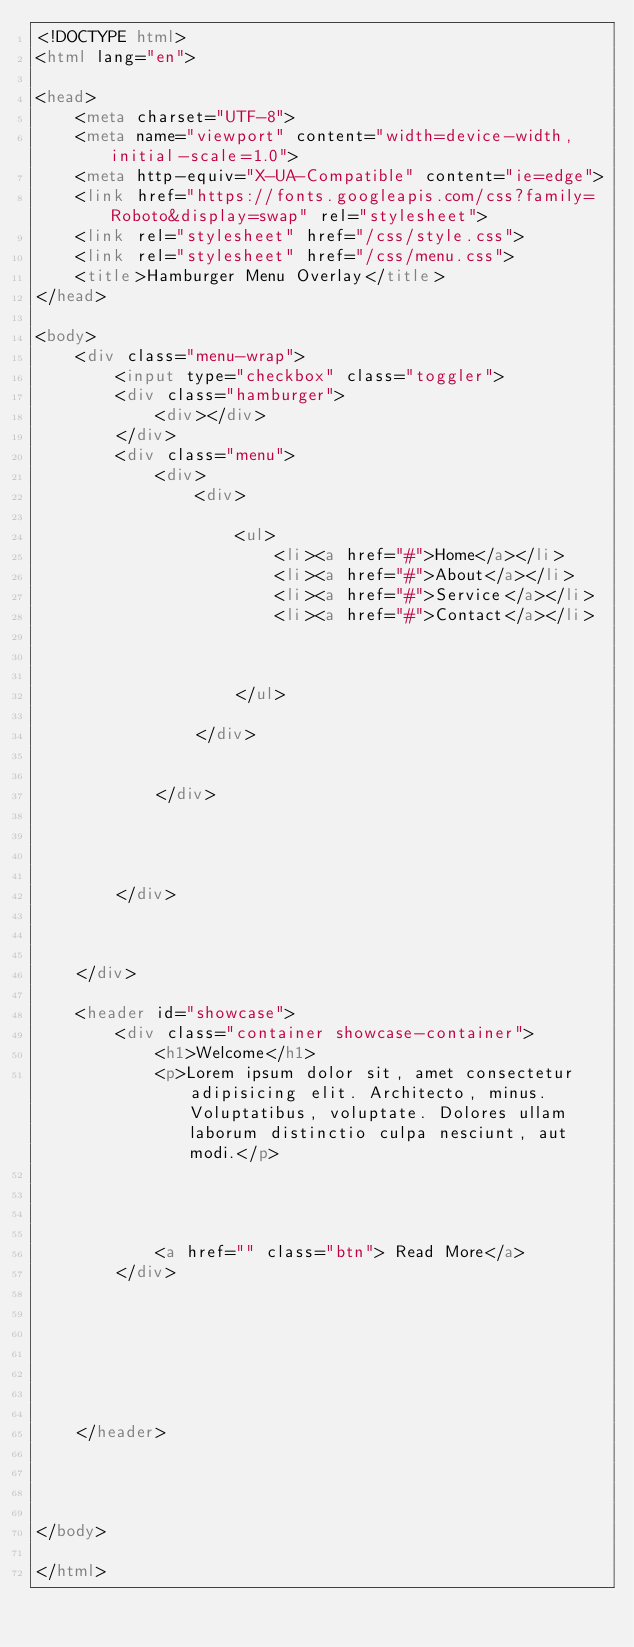Convert code to text. <code><loc_0><loc_0><loc_500><loc_500><_HTML_><!DOCTYPE html>
<html lang="en">

<head>
    <meta charset="UTF-8">
    <meta name="viewport" content="width=device-width, initial-scale=1.0">
    <meta http-equiv="X-UA-Compatible" content="ie=edge">
    <link href="https://fonts.googleapis.com/css?family=Roboto&display=swap" rel="stylesheet">
    <link rel="stylesheet" href="/css/style.css">
    <link rel="stylesheet" href="/css/menu.css">
    <title>Hamburger Menu Overlay</title>
</head>

<body>
    <div class="menu-wrap">
        <input type="checkbox" class="toggler">
        <div class="hamburger">
            <div></div>
        </div>
        <div class="menu">
            <div>
                <div>

                    <ul>
                        <li><a href="#">Home</a></li>
                        <li><a href="#">About</a></li>
                        <li><a href="#">Service</a></li>
                        <li><a href="#">Contact</a></li>



                    </ul>

                </div>


            </div>




        </div>



    </div>

    <header id="showcase">
        <div class="container showcase-container">
            <h1>Welcome</h1>
            <p>Lorem ipsum dolor sit, amet consectetur adipisicing elit. Architecto, minus. Voluptatibus, voluptate. Dolores ullam laborum distinctio culpa nesciunt, aut modi.</p>




            <a href="" class="btn"> Read More</a>
        </div>







    </header>




</body>

</html></code> 